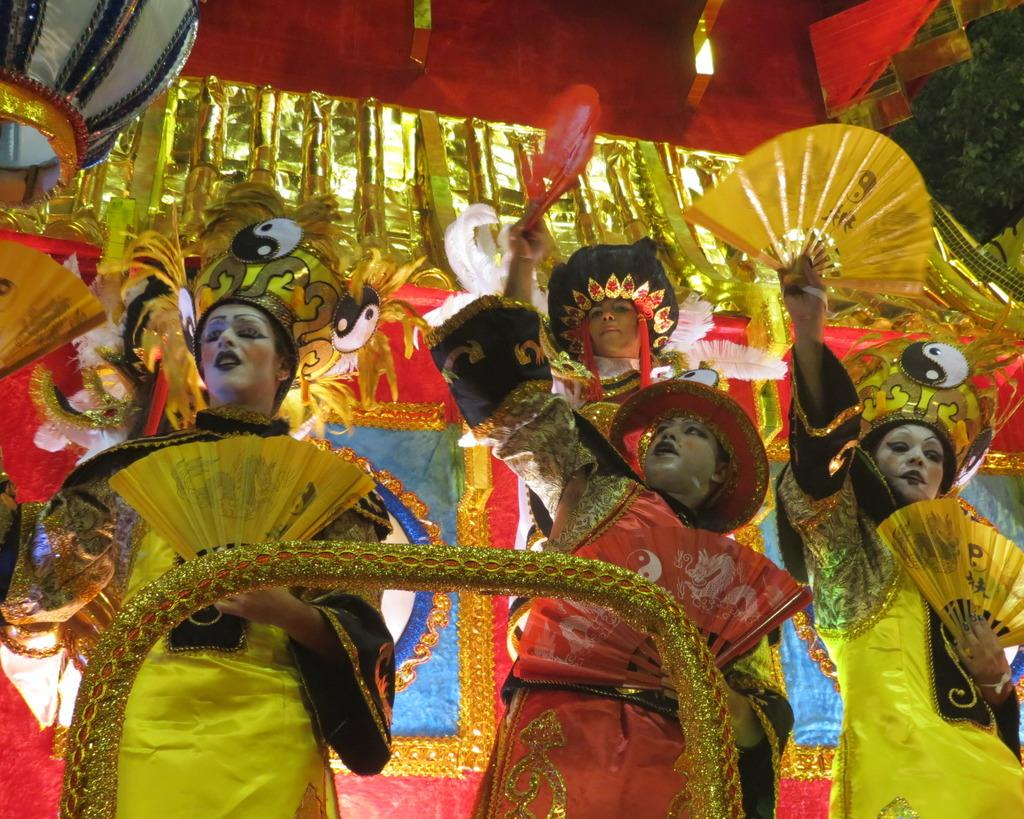What are the people in the foreground of the image wearing? The people in the foreground of the image are wearing masks. What can be seen at the top of the image? There are decorative items visible at the top of the image. What is the background of the image? The background of the image is a well. How is the wall in the image decorated? The wall in the image is decorated. What type of pen is being used to stitch the decorative items in the image? There is no pen or stitching present in the image; the decorative items are not being created or altered in any way. 